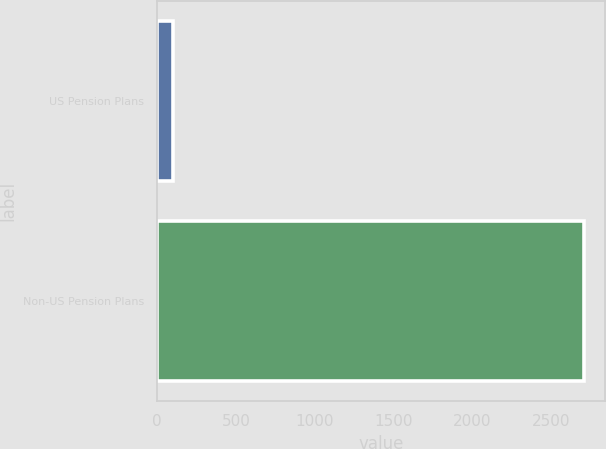Convert chart to OTSL. <chart><loc_0><loc_0><loc_500><loc_500><bar_chart><fcel>US Pension Plans<fcel>Non-US Pension Plans<nl><fcel>102<fcel>2710<nl></chart> 